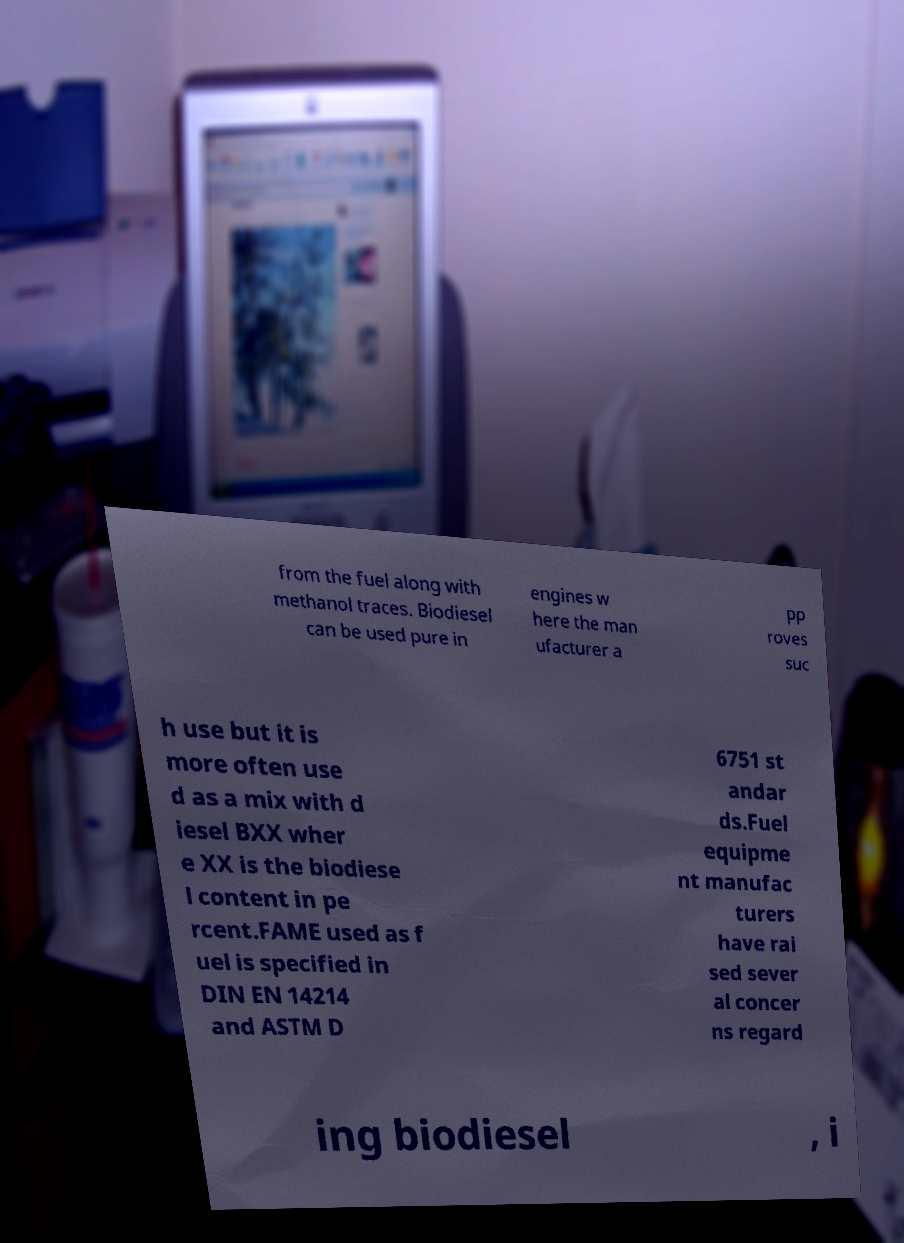Please identify and transcribe the text found in this image. from the fuel along with methanol traces. Biodiesel can be used pure in engines w here the man ufacturer a pp roves suc h use but it is more often use d as a mix with d iesel BXX wher e XX is the biodiese l content in pe rcent.FAME used as f uel is specified in DIN EN 14214 and ASTM D 6751 st andar ds.Fuel equipme nt manufac turers have rai sed sever al concer ns regard ing biodiesel , i 